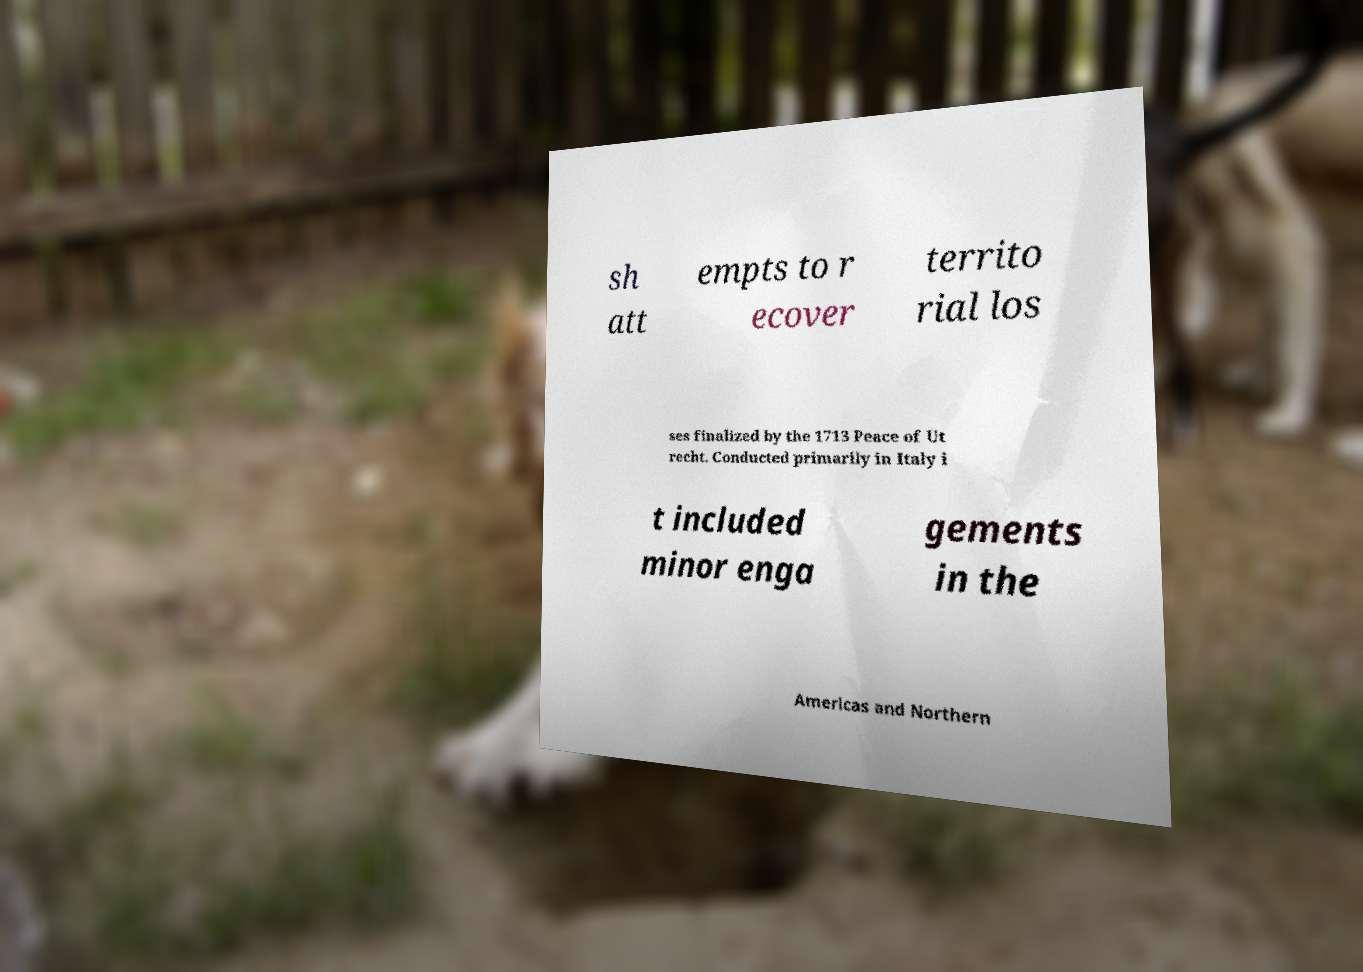What messages or text are displayed in this image? I need them in a readable, typed format. sh att empts to r ecover territo rial los ses finalized by the 1713 Peace of Ut recht. Conducted primarily in Italy i t included minor enga gements in the Americas and Northern 